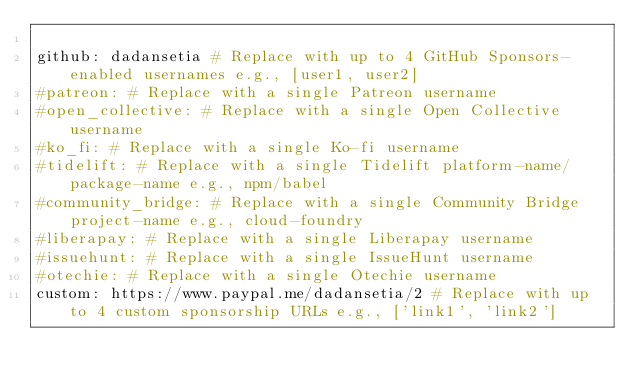<code> <loc_0><loc_0><loc_500><loc_500><_YAML_>
github: dadansetia # Replace with up to 4 GitHub Sponsors-enabled usernames e.g., [user1, user2]
#patreon: # Replace with a single Patreon username
#open_collective: # Replace with a single Open Collective username
#ko_fi: # Replace with a single Ko-fi username
#tidelift: # Replace with a single Tidelift platform-name/package-name e.g., npm/babel
#community_bridge: # Replace with a single Community Bridge project-name e.g., cloud-foundry
#liberapay: # Replace with a single Liberapay username
#issuehunt: # Replace with a single IssueHunt username
#otechie: # Replace with a single Otechie username
custom: https://www.paypal.me/dadansetia/2 # Replace with up to 4 custom sponsorship URLs e.g., ['link1', 'link2']
</code> 